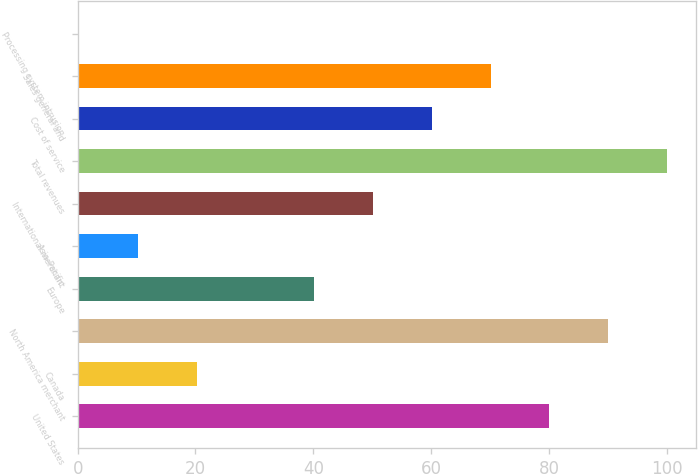Convert chart. <chart><loc_0><loc_0><loc_500><loc_500><bar_chart><fcel>United States<fcel>Canada<fcel>North America merchant<fcel>Europe<fcel>Asia-Pacific<fcel>International merchant<fcel>Total revenues<fcel>Cost of service<fcel>Sales general and<fcel>Processing system intrusion<nl><fcel>80.06<fcel>20.24<fcel>90.03<fcel>40.18<fcel>10.27<fcel>50.15<fcel>100<fcel>60.12<fcel>70.09<fcel>0.3<nl></chart> 